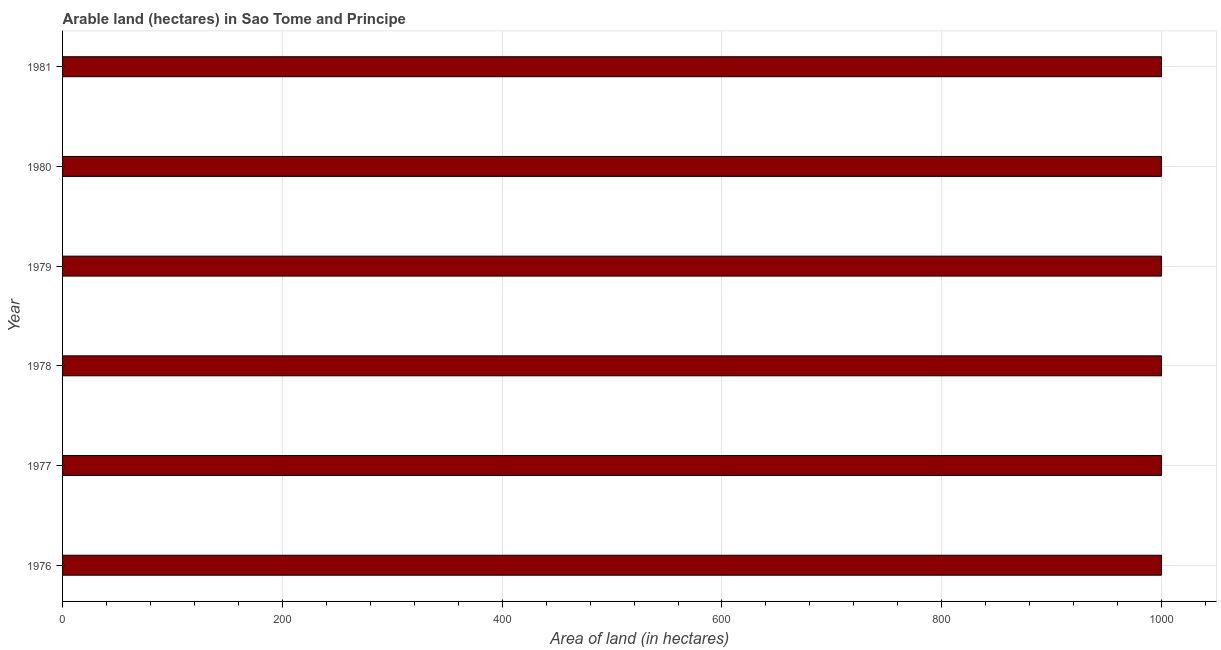Does the graph contain grids?
Your answer should be very brief. Yes. What is the title of the graph?
Offer a terse response. Arable land (hectares) in Sao Tome and Principe. What is the label or title of the X-axis?
Your response must be concise. Area of land (in hectares). What is the area of land in 1976?
Your response must be concise. 1000. Across all years, what is the maximum area of land?
Keep it short and to the point. 1000. Across all years, what is the minimum area of land?
Offer a very short reply. 1000. In which year was the area of land maximum?
Your response must be concise. 1976. In which year was the area of land minimum?
Your response must be concise. 1976. What is the sum of the area of land?
Offer a very short reply. 6000. What is the difference between the area of land in 1980 and 1981?
Keep it short and to the point. 0. What is the median area of land?
Make the answer very short. 1000. In how many years, is the area of land greater than 880 hectares?
Ensure brevity in your answer.  6. What is the ratio of the area of land in 1976 to that in 1979?
Give a very brief answer. 1. Is the area of land in 1977 less than that in 1978?
Make the answer very short. No. Is the difference between the area of land in 1976 and 1980 greater than the difference between any two years?
Give a very brief answer. Yes. What is the difference between the highest and the second highest area of land?
Give a very brief answer. 0. Is the sum of the area of land in 1976 and 1978 greater than the maximum area of land across all years?
Offer a terse response. Yes. What is the difference between the highest and the lowest area of land?
Your response must be concise. 0. Are the values on the major ticks of X-axis written in scientific E-notation?
Offer a terse response. No. What is the Area of land (in hectares) of 1976?
Make the answer very short. 1000. What is the Area of land (in hectares) of 1978?
Your response must be concise. 1000. What is the difference between the Area of land (in hectares) in 1976 and 1979?
Make the answer very short. 0. What is the difference between the Area of land (in hectares) in 1977 and 1979?
Offer a terse response. 0. What is the difference between the Area of land (in hectares) in 1978 and 1979?
Your response must be concise. 0. What is the difference between the Area of land (in hectares) in 1978 and 1980?
Give a very brief answer. 0. What is the difference between the Area of land (in hectares) in 1978 and 1981?
Ensure brevity in your answer.  0. What is the ratio of the Area of land (in hectares) in 1976 to that in 1977?
Provide a succinct answer. 1. What is the ratio of the Area of land (in hectares) in 1976 to that in 1978?
Keep it short and to the point. 1. What is the ratio of the Area of land (in hectares) in 1977 to that in 1979?
Keep it short and to the point. 1. What is the ratio of the Area of land (in hectares) in 1977 to that in 1981?
Ensure brevity in your answer.  1. What is the ratio of the Area of land (in hectares) in 1978 to that in 1979?
Ensure brevity in your answer.  1. What is the ratio of the Area of land (in hectares) in 1978 to that in 1980?
Keep it short and to the point. 1. What is the ratio of the Area of land (in hectares) in 1978 to that in 1981?
Your answer should be very brief. 1. What is the ratio of the Area of land (in hectares) in 1980 to that in 1981?
Provide a succinct answer. 1. 